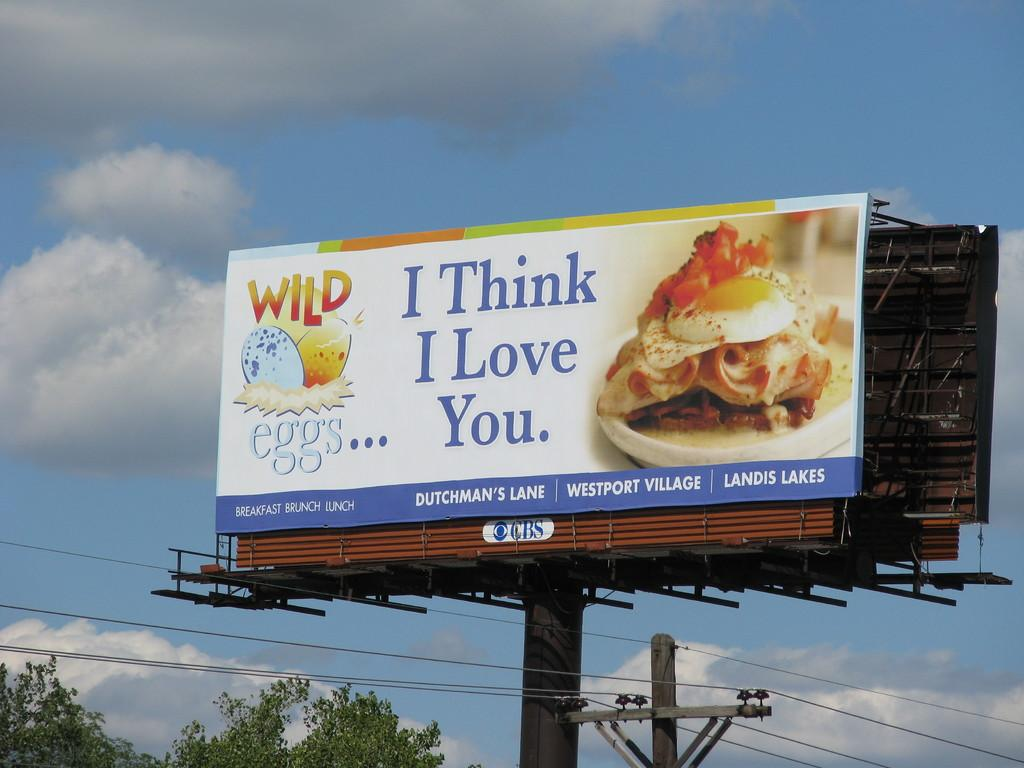<image>
Relay a brief, clear account of the picture shown. A large billboard shows an egg sandwich and says I Think I Love You. 